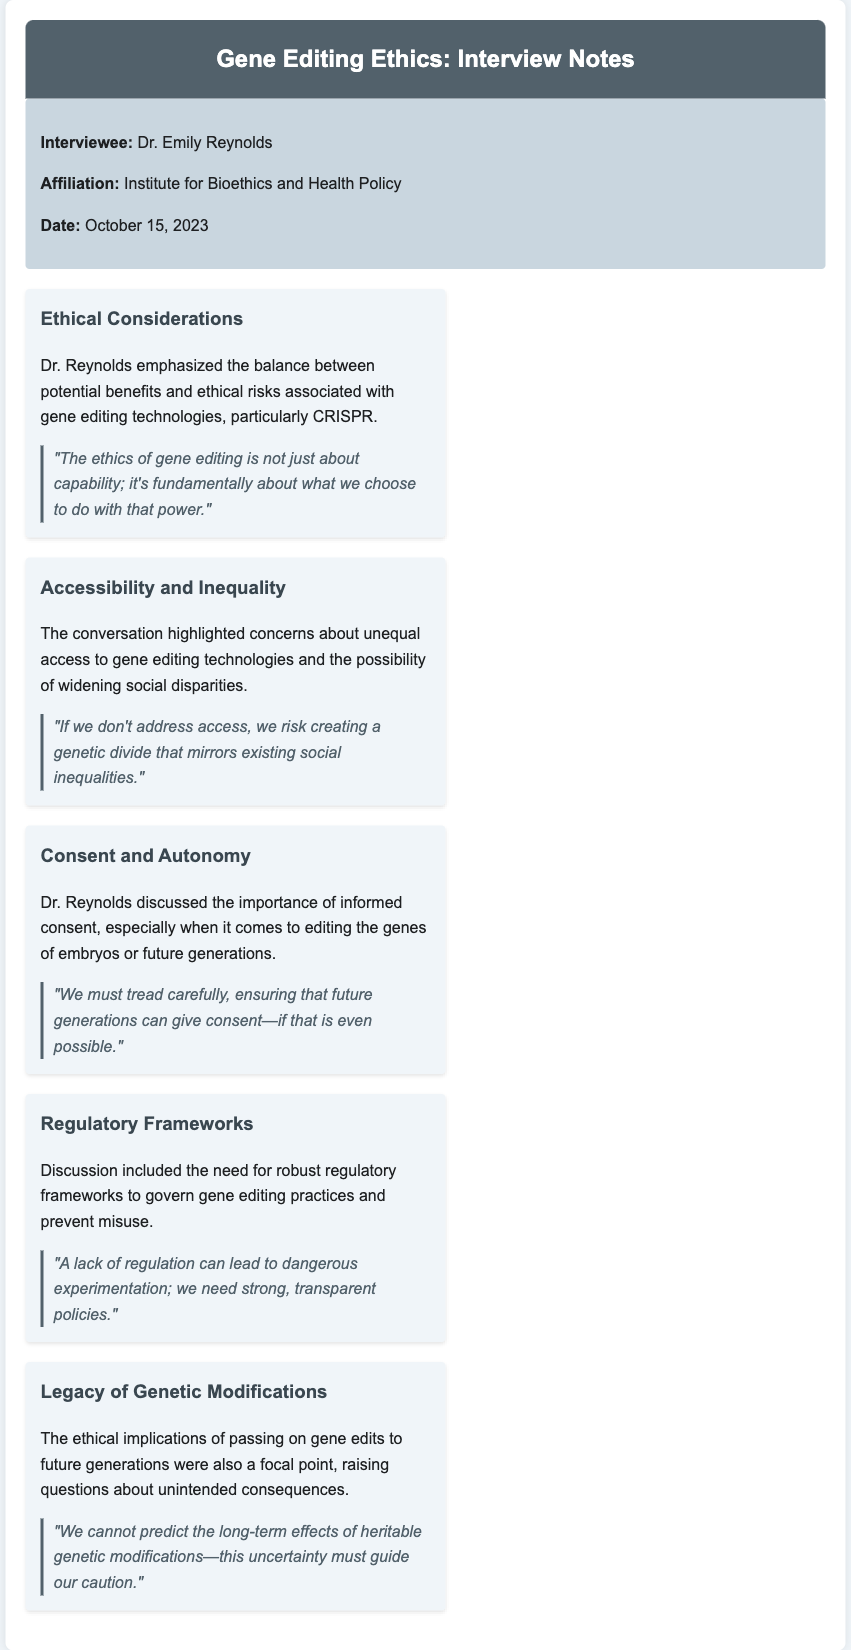What is the name of the interviewee? The name of the interviewee is mentioned in the document as Dr. Emily Reynolds.
Answer: Dr. Emily Reynolds What is the date of the interview? The date of the interview is explicitly stated in the document as October 15, 2023.
Answer: October 15, 2023 What affiliation does Dr. Reynolds represent? The document provides the affiliation of Dr. Reynolds as the Institute for Bioethics and Health Policy.
Answer: Institute for Bioethics and Health Policy Which gene editing technology is specifically mentioned? The document mentions CRISPR as a key technology in the discussion of gene editing ethics.
Answer: CRISPR What key ethical consideration did Dr. Reynolds emphasize? Dr. Reynolds emphasized the balance between potential benefits and ethical risks associated with gene editing technologies.
Answer: Balance between potential benefits and ethical risks What are the consequences of not addressing access to gene editing technologies? The document highlights concerns about creating a genetic divide that mirrors existing social inequalities.
Answer: Creating a genetic divide What is a challenge related to informed consent in gene editing? The document discusses the importance of ensuring future generations can give consent for gene editing.
Answer: Future generations can give consent What does Dr. Reynolds say about regulatory frameworks? The document mentions the need for strong, transparent policies to govern gene editing practices.
Answer: Strong, transparent policies How does Dr. Reynolds view the long-term effects of genetic modifications? The document states that the long-term effects of heritable genetic modifications are uncertain, necessitating caution.
Answer: Long-term effects are uncertain 